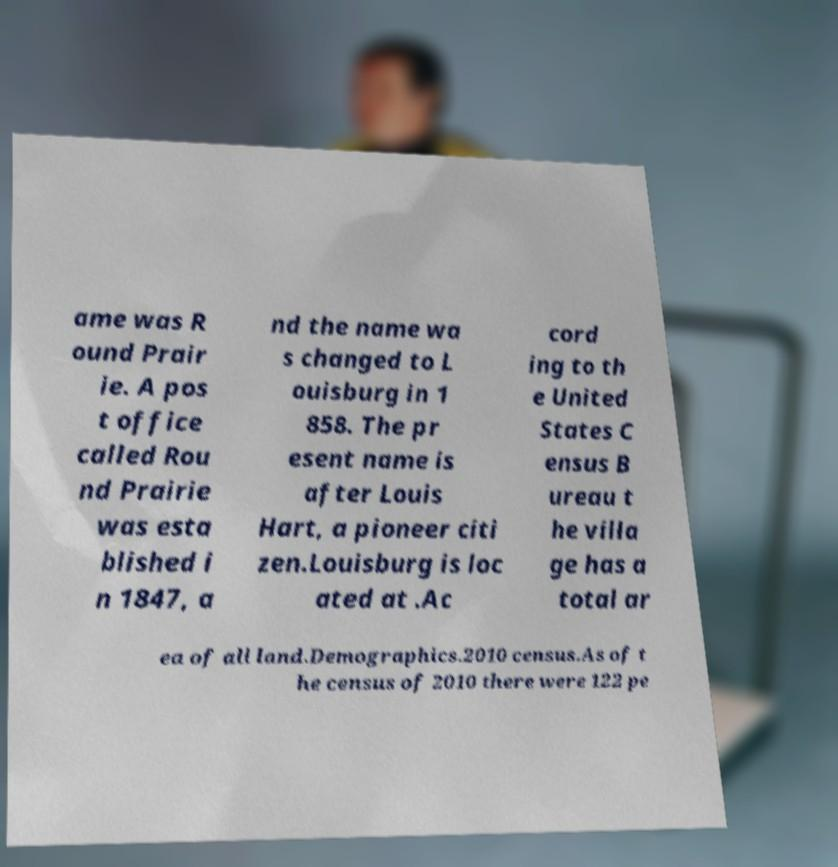I need the written content from this picture converted into text. Can you do that? ame was R ound Prair ie. A pos t office called Rou nd Prairie was esta blished i n 1847, a nd the name wa s changed to L ouisburg in 1 858. The pr esent name is after Louis Hart, a pioneer citi zen.Louisburg is loc ated at .Ac cord ing to th e United States C ensus B ureau t he villa ge has a total ar ea of all land.Demographics.2010 census.As of t he census of 2010 there were 122 pe 